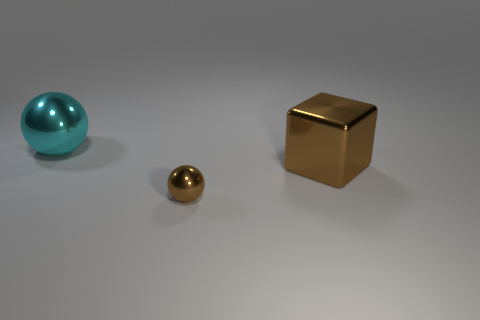What number of large metallic objects are the same color as the small object?
Offer a very short reply. 1. Are there more metallic spheres on the left side of the big sphere than tiny shiny things on the left side of the large metallic block?
Ensure brevity in your answer.  No. How many cyan spheres are the same material as the cyan thing?
Make the answer very short. 0. Is the shape of the large metallic object that is in front of the cyan metallic sphere the same as the object that is left of the tiny metallic sphere?
Provide a succinct answer. No. The metal sphere that is on the left side of the tiny metallic ball is what color?
Ensure brevity in your answer.  Cyan. Is there a tiny yellow object of the same shape as the big cyan shiny thing?
Your answer should be very brief. No. What is the material of the cyan ball?
Offer a terse response. Metal. There is a metal thing that is both behind the tiny thing and in front of the cyan shiny ball; what size is it?
Provide a succinct answer. Large. There is a large block that is the same color as the tiny shiny ball; what is it made of?
Give a very brief answer. Metal. What number of brown cubes are there?
Make the answer very short. 1. 